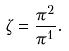Convert formula to latex. <formula><loc_0><loc_0><loc_500><loc_500>\zeta = \frac { \pi ^ { 2 } } { \pi ^ { 1 } } .</formula> 